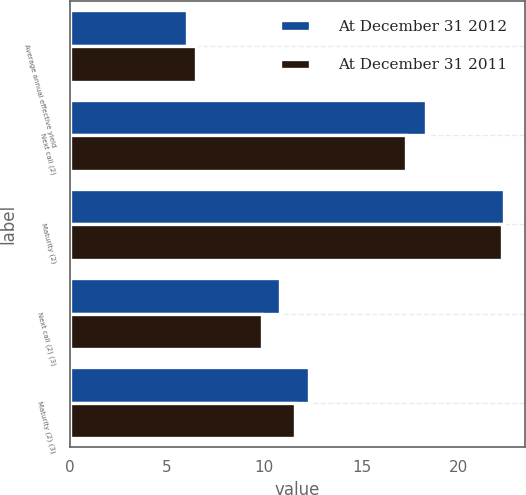Convert chart. <chart><loc_0><loc_0><loc_500><loc_500><stacked_bar_chart><ecel><fcel>Average annual effective yield<fcel>Next call (2)<fcel>Maturity (2)<fcel>Next call (2) (3)<fcel>Maturity (2) (3)<nl><fcel>At December 31 2012<fcel>6.04<fcel>18.3<fcel>22.3<fcel>10.8<fcel>12.3<nl><fcel>At December 31 2011<fcel>6.49<fcel>17.3<fcel>22.2<fcel>9.9<fcel>11.6<nl></chart> 